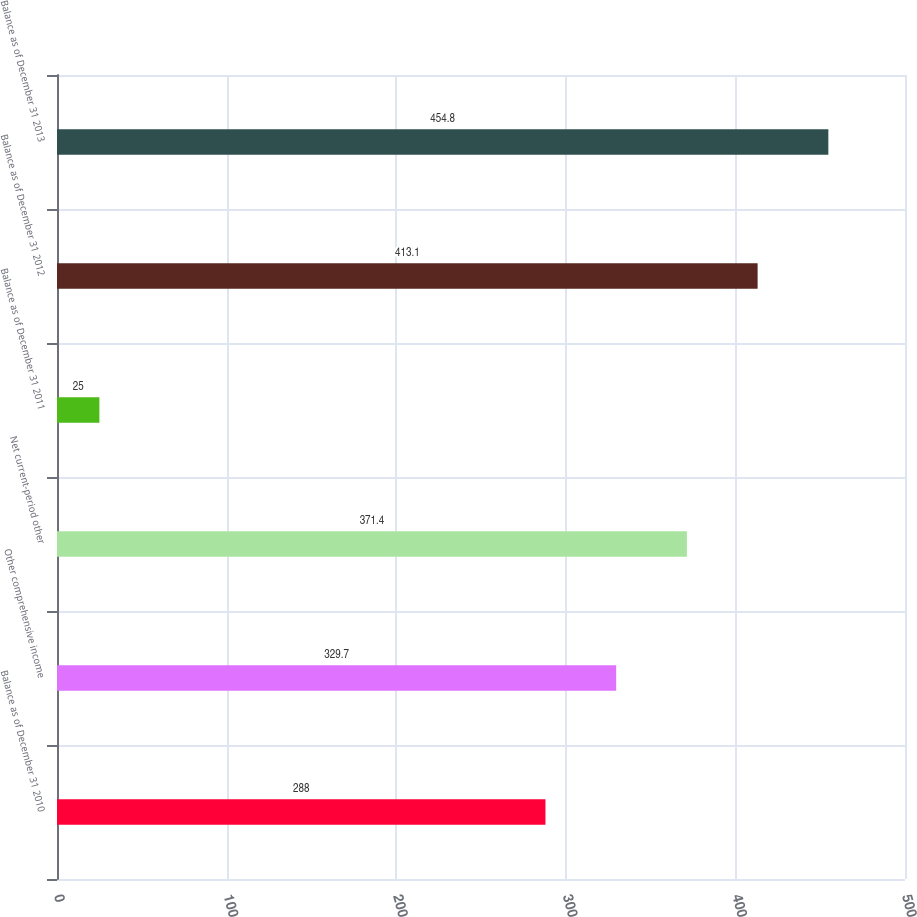<chart> <loc_0><loc_0><loc_500><loc_500><bar_chart><fcel>Balance as of December 31 2010<fcel>Other comprehensive income<fcel>Net current-period other<fcel>Balance as of December 31 2011<fcel>Balance as of December 31 2012<fcel>Balance as of December 31 2013<nl><fcel>288<fcel>329.7<fcel>371.4<fcel>25<fcel>413.1<fcel>454.8<nl></chart> 